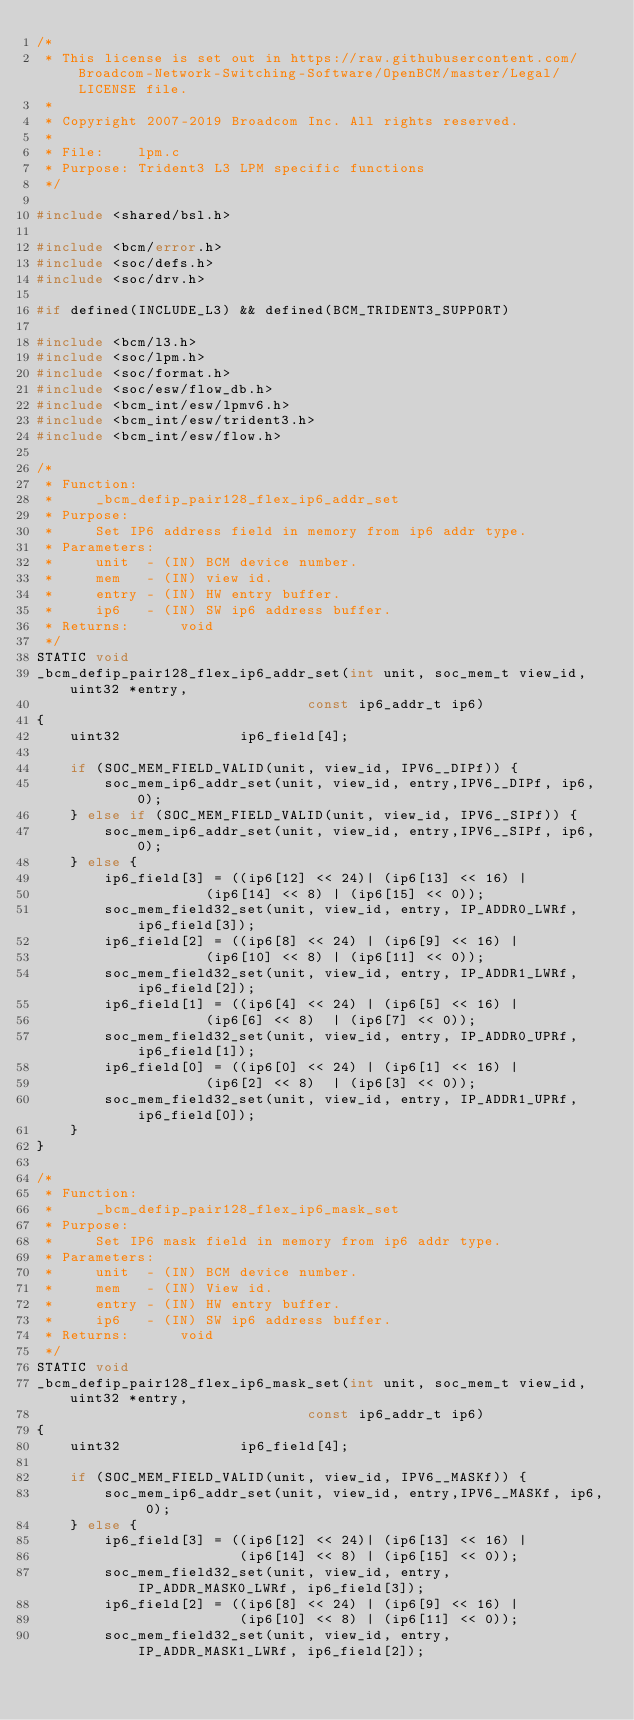<code> <loc_0><loc_0><loc_500><loc_500><_C_>/*
 * This license is set out in https://raw.githubusercontent.com/Broadcom-Network-Switching-Software/OpenBCM/master/Legal/LICENSE file.
 * 
 * Copyright 2007-2019 Broadcom Inc. All rights reserved.
 *
 * File:    lpm.c
 * Purpose: Trident3 L3 LPM specific functions
 */

#include <shared/bsl.h>

#include <bcm/error.h>
#include <soc/defs.h>
#include <soc/drv.h>

#if defined(INCLUDE_L3) && defined(BCM_TRIDENT3_SUPPORT) 

#include <bcm/l3.h>
#include <soc/lpm.h>
#include <soc/format.h>
#include <soc/esw/flow_db.h>
#include <bcm_int/esw/lpmv6.h>
#include <bcm_int/esw/trident3.h>
#include <bcm_int/esw/flow.h>

/*
 * Function:    
 *     _bcm_defip_pair128_flex_ip6_addr_set
 * Purpose:  
 *     Set IP6 address field in memory from ip6 addr type. 
 * Parameters: 
 *     unit  - (IN) BCM device number. 
 *     mem   - (IN) view id.
 *     entry - (IN) HW entry buffer.
 *     ip6   - (IN) SW ip6 address buffer.
 * Returns:      void
 */
STATIC void
_bcm_defip_pair128_flex_ip6_addr_set(int unit, soc_mem_t view_id, uint32 *entry, 
                                const ip6_addr_t ip6)
{
    uint32              ip6_field[4];

    if (SOC_MEM_FIELD_VALID(unit, view_id, IPV6__DIPf)) {
        soc_mem_ip6_addr_set(unit, view_id, entry,IPV6__DIPf, ip6, 0);
    } else if (SOC_MEM_FIELD_VALID(unit, view_id, IPV6__SIPf)) {
        soc_mem_ip6_addr_set(unit, view_id, entry,IPV6__SIPf, ip6, 0);
    } else {
        ip6_field[3] = ((ip6[12] << 24)| (ip6[13] << 16) |
                    (ip6[14] << 8) | (ip6[15] << 0));
        soc_mem_field32_set(unit, view_id, entry, IP_ADDR0_LWRf, ip6_field[3]);
        ip6_field[2] = ((ip6[8] << 24) | (ip6[9] << 16) |
                    (ip6[10] << 8) | (ip6[11] << 0));
        soc_mem_field32_set(unit, view_id, entry, IP_ADDR1_LWRf, ip6_field[2]);
        ip6_field[1] = ((ip6[4] << 24) | (ip6[5] << 16) |
                    (ip6[6] << 8)  | (ip6[7] << 0));
        soc_mem_field32_set(unit, view_id, entry, IP_ADDR0_UPRf, ip6_field[1]);
        ip6_field[0] = ((ip6[0] << 24) | (ip6[1] << 16) |
                    (ip6[2] << 8)  | (ip6[3] << 0));
        soc_mem_field32_set(unit, view_id, entry, IP_ADDR1_UPRf, ip6_field[0]);
    }
}

/*
 * Function:    
 *     _bcm_defip_pair128_flex_ip6_mask_set
 * Purpose:  
 *     Set IP6 mask field in memory from ip6 addr type. 
 * Parameters: 
 *     unit  - (IN) BCM device number. 
 *     mem   - (IN) View id.
 *     entry - (IN) HW entry buffer.
 *     ip6   - (IN) SW ip6 address buffer.
 * Returns:      void
 */
STATIC void
_bcm_defip_pair128_flex_ip6_mask_set(int unit, soc_mem_t view_id, uint32 *entry, 
                                const ip6_addr_t ip6)
{
    uint32              ip6_field[4];

    if (SOC_MEM_FIELD_VALID(unit, view_id, IPV6__MASKf)) {
        soc_mem_ip6_addr_set(unit, view_id, entry,IPV6__MASKf, ip6, 0);
    } else {
        ip6_field[3] = ((ip6[12] << 24)| (ip6[13] << 16) |
                        (ip6[14] << 8) | (ip6[15] << 0));
        soc_mem_field32_set(unit, view_id, entry, IP_ADDR_MASK0_LWRf, ip6_field[3]);
        ip6_field[2] = ((ip6[8] << 24) | (ip6[9] << 16) |
                        (ip6[10] << 8) | (ip6[11] << 0));
        soc_mem_field32_set(unit, view_id, entry, IP_ADDR_MASK1_LWRf, ip6_field[2]);</code> 